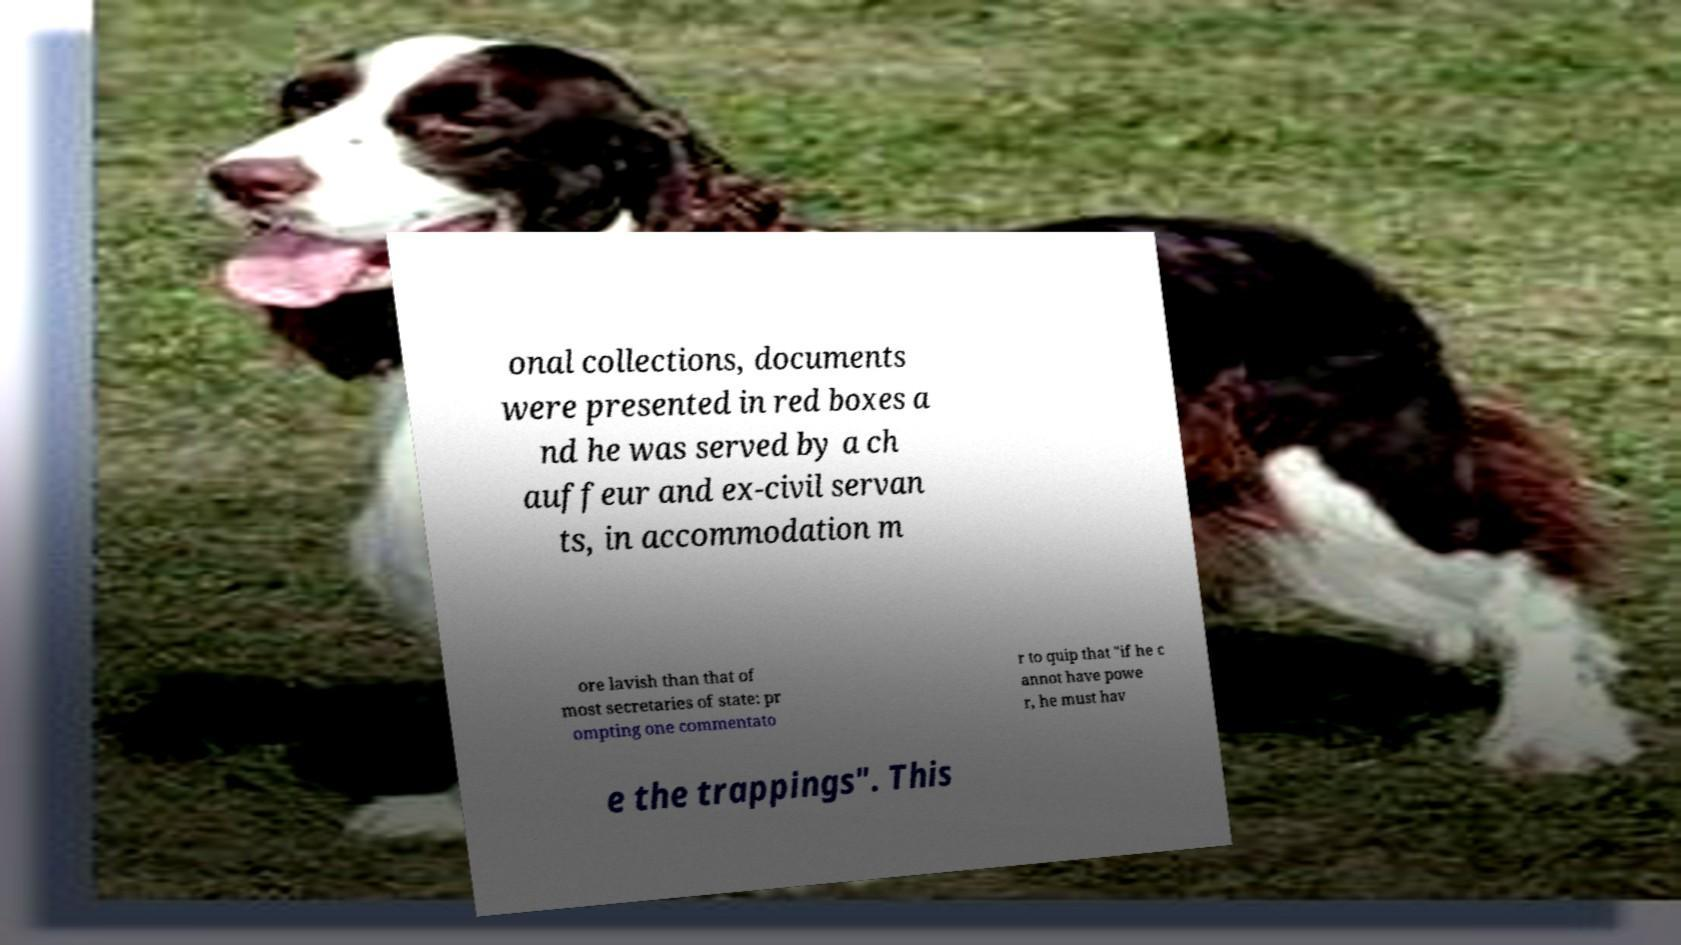Could you assist in decoding the text presented in this image and type it out clearly? onal collections, documents were presented in red boxes a nd he was served by a ch auffeur and ex-civil servan ts, in accommodation m ore lavish than that of most secretaries of state: pr ompting one commentato r to quip that "if he c annot have powe r, he must hav e the trappings". This 